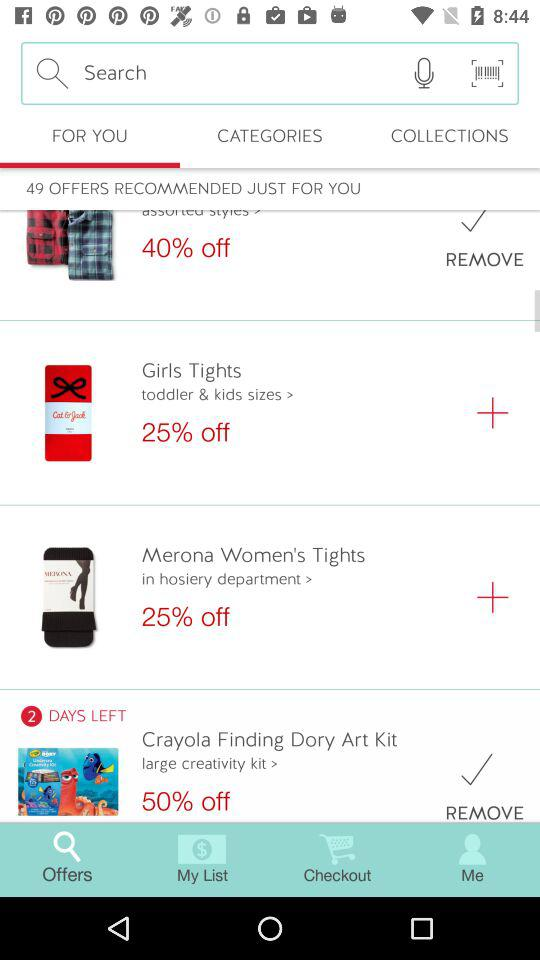How much is a discount on "Merona Women's Tights"? There is 50% discount. 